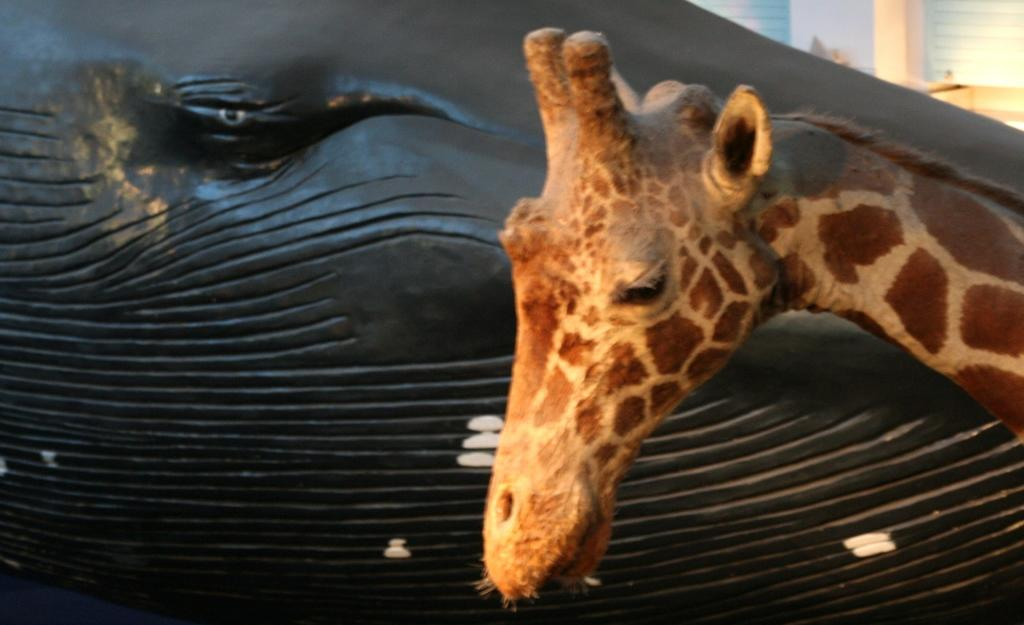What type of animal is depicted in the image? There is an artificial giraffe in the image. On which side of the image is the giraffe located? The giraffe is on the right side of the image. What type of material can be seen in the image? There is black-colored wood in the image. What can be seen in the background of the image? There are glass windows visible in the background of the image. What type of quince is being used to support the artificial giraffe in the image? There is no quince present in the image; it features an artificial giraffe and black-colored wood. How many feet can be seen supporting the artificial giraffe in the image? There are no feet visible in the image, as the giraffe is artificial and not a real animal. 